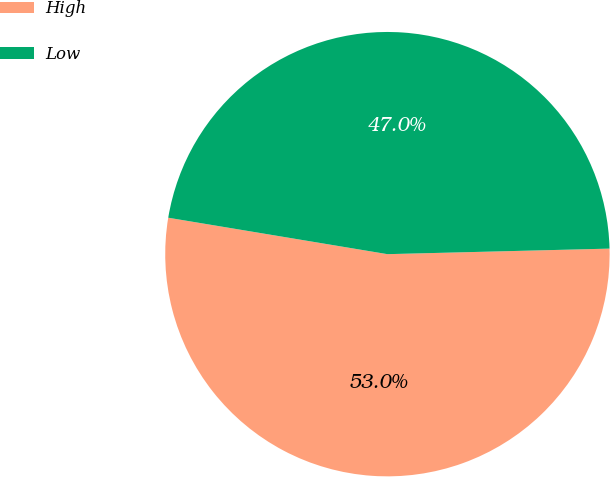Convert chart to OTSL. <chart><loc_0><loc_0><loc_500><loc_500><pie_chart><fcel>High<fcel>Low<nl><fcel>53.02%<fcel>46.98%<nl></chart> 